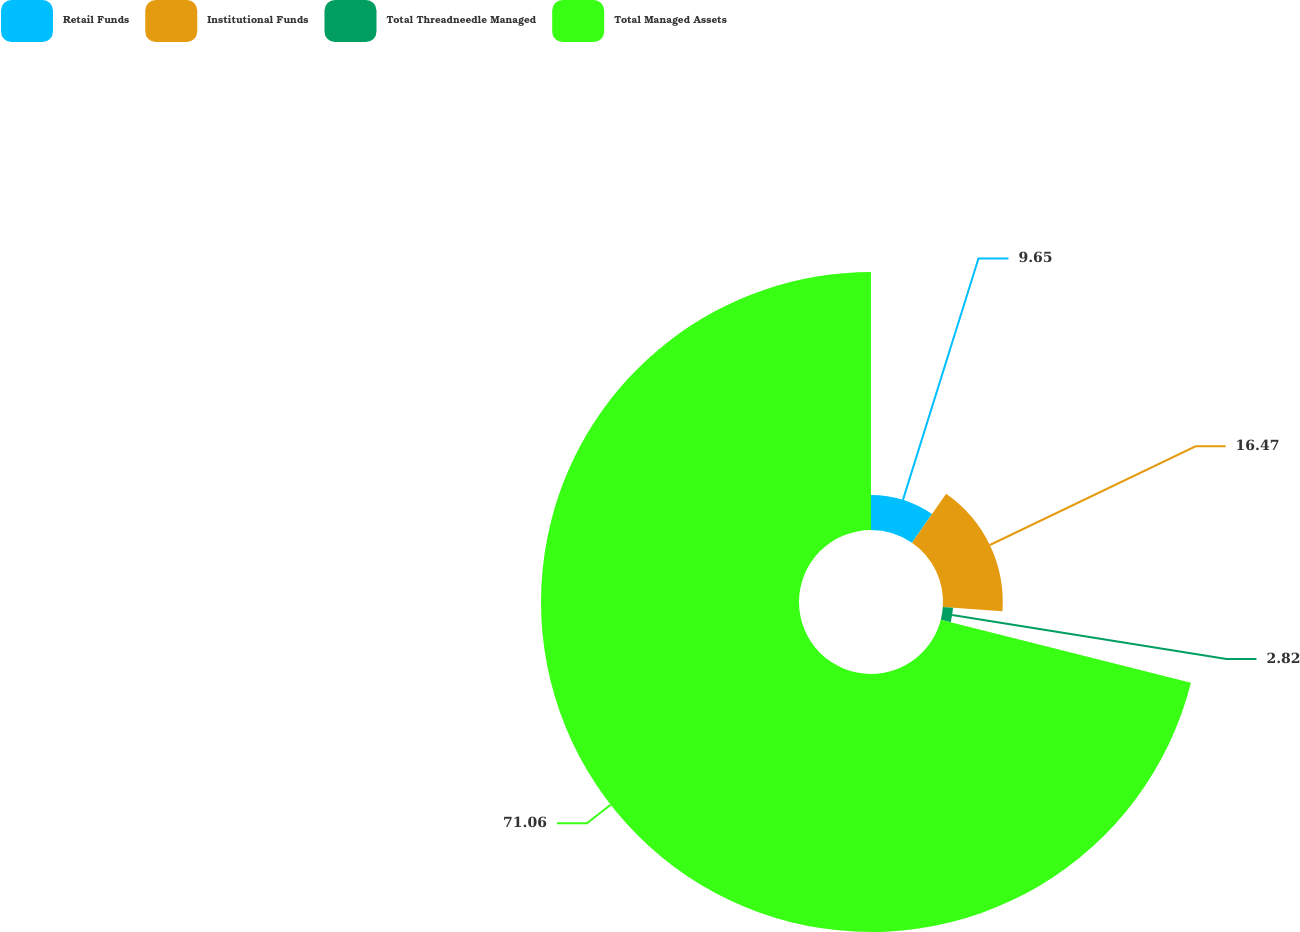<chart> <loc_0><loc_0><loc_500><loc_500><pie_chart><fcel>Retail Funds<fcel>Institutional Funds<fcel>Total Threadneedle Managed<fcel>Total Managed Assets<nl><fcel>9.65%<fcel>16.47%<fcel>2.82%<fcel>71.06%<nl></chart> 